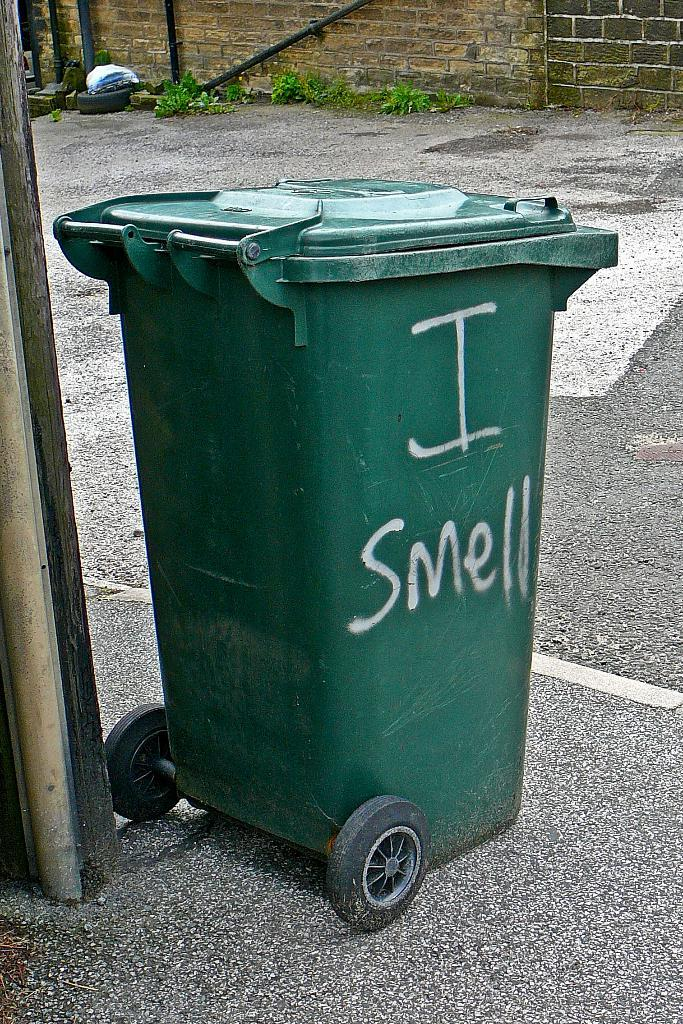Provide a one-sentence caption for the provided image. A green garbage dumpster with the words I Smell written on it on the side on a street. 